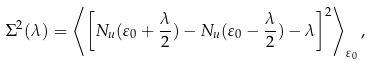<formula> <loc_0><loc_0><loc_500><loc_500>\Sigma ^ { 2 } ( \lambda ) = \left \langle \left [ N _ { u } ( \varepsilon _ { 0 } + \frac { \lambda } { 2 } ) - N _ { u } ( \varepsilon _ { 0 } - \frac { \lambda } { 2 } ) - \lambda \right ] ^ { 2 } \right \rangle _ { \varepsilon _ { 0 } } ,</formula> 